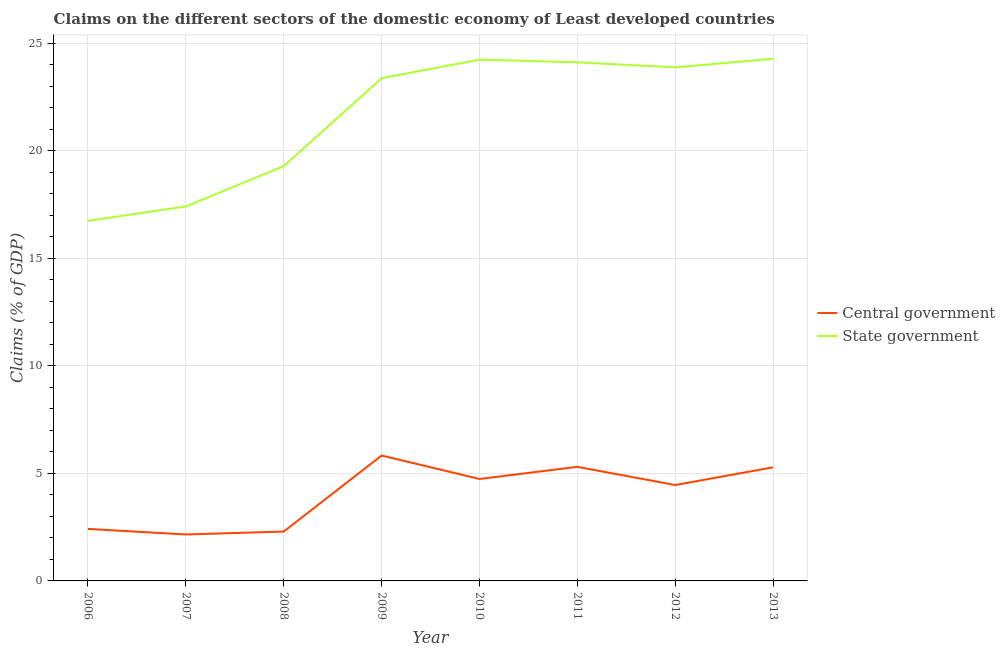Does the line corresponding to claims on central government intersect with the line corresponding to claims on state government?
Ensure brevity in your answer.  No. Is the number of lines equal to the number of legend labels?
Provide a succinct answer. Yes. What is the claims on central government in 2008?
Make the answer very short. 2.3. Across all years, what is the maximum claims on state government?
Make the answer very short. 24.27. Across all years, what is the minimum claims on central government?
Your answer should be very brief. 2.16. In which year was the claims on central government maximum?
Give a very brief answer. 2009. What is the total claims on central government in the graph?
Offer a terse response. 32.48. What is the difference between the claims on central government in 2007 and that in 2010?
Offer a terse response. -2.58. What is the difference between the claims on central government in 2011 and the claims on state government in 2009?
Your response must be concise. -18.06. What is the average claims on state government per year?
Ensure brevity in your answer.  21.66. In the year 2010, what is the difference between the claims on state government and claims on central government?
Your response must be concise. 19.49. What is the ratio of the claims on central government in 2008 to that in 2011?
Offer a very short reply. 0.43. Is the claims on central government in 2009 less than that in 2011?
Your response must be concise. No. What is the difference between the highest and the second highest claims on state government?
Keep it short and to the point. 0.05. What is the difference between the highest and the lowest claims on state government?
Provide a short and direct response. 7.54. In how many years, is the claims on state government greater than the average claims on state government taken over all years?
Provide a short and direct response. 5. Is the claims on state government strictly less than the claims on central government over the years?
Offer a very short reply. No. How many lines are there?
Provide a succinct answer. 2. Are the values on the major ticks of Y-axis written in scientific E-notation?
Ensure brevity in your answer.  No. Does the graph contain any zero values?
Ensure brevity in your answer.  No. How many legend labels are there?
Provide a short and direct response. 2. What is the title of the graph?
Keep it short and to the point. Claims on the different sectors of the domestic economy of Least developed countries. Does "Male labourers" appear as one of the legend labels in the graph?
Offer a terse response. No. What is the label or title of the Y-axis?
Your response must be concise. Claims (% of GDP). What is the Claims (% of GDP) of Central government in 2006?
Your answer should be compact. 2.42. What is the Claims (% of GDP) in State government in 2006?
Offer a terse response. 16.74. What is the Claims (% of GDP) in Central government in 2007?
Your response must be concise. 2.16. What is the Claims (% of GDP) in State government in 2007?
Your response must be concise. 17.41. What is the Claims (% of GDP) in Central government in 2008?
Make the answer very short. 2.3. What is the Claims (% of GDP) in State government in 2008?
Provide a succinct answer. 19.28. What is the Claims (% of GDP) of Central government in 2009?
Your response must be concise. 5.83. What is the Claims (% of GDP) of State government in 2009?
Ensure brevity in your answer.  23.37. What is the Claims (% of GDP) of Central government in 2010?
Keep it short and to the point. 4.74. What is the Claims (% of GDP) in State government in 2010?
Offer a terse response. 24.23. What is the Claims (% of GDP) of Central government in 2011?
Give a very brief answer. 5.3. What is the Claims (% of GDP) in State government in 2011?
Make the answer very short. 24.11. What is the Claims (% of GDP) of Central government in 2012?
Give a very brief answer. 4.46. What is the Claims (% of GDP) of State government in 2012?
Your answer should be very brief. 23.87. What is the Claims (% of GDP) in Central government in 2013?
Make the answer very short. 5.28. What is the Claims (% of GDP) in State government in 2013?
Provide a succinct answer. 24.27. Across all years, what is the maximum Claims (% of GDP) in Central government?
Provide a short and direct response. 5.83. Across all years, what is the maximum Claims (% of GDP) in State government?
Offer a very short reply. 24.27. Across all years, what is the minimum Claims (% of GDP) of Central government?
Provide a short and direct response. 2.16. Across all years, what is the minimum Claims (% of GDP) of State government?
Provide a short and direct response. 16.74. What is the total Claims (% of GDP) in Central government in the graph?
Keep it short and to the point. 32.48. What is the total Claims (% of GDP) in State government in the graph?
Provide a short and direct response. 173.27. What is the difference between the Claims (% of GDP) of Central government in 2006 and that in 2007?
Give a very brief answer. 0.26. What is the difference between the Claims (% of GDP) of State government in 2006 and that in 2007?
Offer a terse response. -0.67. What is the difference between the Claims (% of GDP) of Central government in 2006 and that in 2008?
Keep it short and to the point. 0.12. What is the difference between the Claims (% of GDP) in State government in 2006 and that in 2008?
Keep it short and to the point. -2.55. What is the difference between the Claims (% of GDP) in Central government in 2006 and that in 2009?
Offer a very short reply. -3.41. What is the difference between the Claims (% of GDP) of State government in 2006 and that in 2009?
Ensure brevity in your answer.  -6.63. What is the difference between the Claims (% of GDP) in Central government in 2006 and that in 2010?
Offer a very short reply. -2.32. What is the difference between the Claims (% of GDP) of State government in 2006 and that in 2010?
Your response must be concise. -7.49. What is the difference between the Claims (% of GDP) in Central government in 2006 and that in 2011?
Give a very brief answer. -2.89. What is the difference between the Claims (% of GDP) of State government in 2006 and that in 2011?
Provide a succinct answer. -7.37. What is the difference between the Claims (% of GDP) in Central government in 2006 and that in 2012?
Keep it short and to the point. -2.04. What is the difference between the Claims (% of GDP) of State government in 2006 and that in 2012?
Your response must be concise. -7.13. What is the difference between the Claims (% of GDP) in Central government in 2006 and that in 2013?
Provide a short and direct response. -2.86. What is the difference between the Claims (% of GDP) in State government in 2006 and that in 2013?
Offer a terse response. -7.54. What is the difference between the Claims (% of GDP) in Central government in 2007 and that in 2008?
Offer a very short reply. -0.14. What is the difference between the Claims (% of GDP) of State government in 2007 and that in 2008?
Offer a terse response. -1.88. What is the difference between the Claims (% of GDP) of Central government in 2007 and that in 2009?
Provide a short and direct response. -3.67. What is the difference between the Claims (% of GDP) of State government in 2007 and that in 2009?
Ensure brevity in your answer.  -5.96. What is the difference between the Claims (% of GDP) of Central government in 2007 and that in 2010?
Provide a short and direct response. -2.58. What is the difference between the Claims (% of GDP) in State government in 2007 and that in 2010?
Offer a very short reply. -6.82. What is the difference between the Claims (% of GDP) in Central government in 2007 and that in 2011?
Make the answer very short. -3.14. What is the difference between the Claims (% of GDP) of State government in 2007 and that in 2011?
Keep it short and to the point. -6.7. What is the difference between the Claims (% of GDP) in Central government in 2007 and that in 2012?
Your answer should be very brief. -2.3. What is the difference between the Claims (% of GDP) of State government in 2007 and that in 2012?
Give a very brief answer. -6.46. What is the difference between the Claims (% of GDP) of Central government in 2007 and that in 2013?
Keep it short and to the point. -3.12. What is the difference between the Claims (% of GDP) of State government in 2007 and that in 2013?
Offer a terse response. -6.87. What is the difference between the Claims (% of GDP) in Central government in 2008 and that in 2009?
Give a very brief answer. -3.53. What is the difference between the Claims (% of GDP) of State government in 2008 and that in 2009?
Provide a short and direct response. -4.08. What is the difference between the Claims (% of GDP) of Central government in 2008 and that in 2010?
Your answer should be compact. -2.44. What is the difference between the Claims (% of GDP) in State government in 2008 and that in 2010?
Offer a very short reply. -4.95. What is the difference between the Claims (% of GDP) of Central government in 2008 and that in 2011?
Offer a very short reply. -3.01. What is the difference between the Claims (% of GDP) of State government in 2008 and that in 2011?
Offer a very short reply. -4.82. What is the difference between the Claims (% of GDP) of Central government in 2008 and that in 2012?
Offer a terse response. -2.16. What is the difference between the Claims (% of GDP) in State government in 2008 and that in 2012?
Your response must be concise. -4.59. What is the difference between the Claims (% of GDP) of Central government in 2008 and that in 2013?
Your response must be concise. -2.99. What is the difference between the Claims (% of GDP) in State government in 2008 and that in 2013?
Offer a very short reply. -4.99. What is the difference between the Claims (% of GDP) in Central government in 2009 and that in 2010?
Your answer should be very brief. 1.09. What is the difference between the Claims (% of GDP) in State government in 2009 and that in 2010?
Your answer should be very brief. -0.86. What is the difference between the Claims (% of GDP) in Central government in 2009 and that in 2011?
Provide a succinct answer. 0.53. What is the difference between the Claims (% of GDP) of State government in 2009 and that in 2011?
Provide a succinct answer. -0.74. What is the difference between the Claims (% of GDP) of Central government in 2009 and that in 2012?
Make the answer very short. 1.37. What is the difference between the Claims (% of GDP) of State government in 2009 and that in 2012?
Ensure brevity in your answer.  -0.5. What is the difference between the Claims (% of GDP) of Central government in 2009 and that in 2013?
Offer a terse response. 0.55. What is the difference between the Claims (% of GDP) in State government in 2009 and that in 2013?
Your response must be concise. -0.91. What is the difference between the Claims (% of GDP) in Central government in 2010 and that in 2011?
Provide a succinct answer. -0.56. What is the difference between the Claims (% of GDP) in State government in 2010 and that in 2011?
Ensure brevity in your answer.  0.12. What is the difference between the Claims (% of GDP) of Central government in 2010 and that in 2012?
Provide a succinct answer. 0.28. What is the difference between the Claims (% of GDP) in State government in 2010 and that in 2012?
Your answer should be very brief. 0.36. What is the difference between the Claims (% of GDP) in Central government in 2010 and that in 2013?
Offer a very short reply. -0.54. What is the difference between the Claims (% of GDP) of State government in 2010 and that in 2013?
Your response must be concise. -0.05. What is the difference between the Claims (% of GDP) in Central government in 2011 and that in 2012?
Your answer should be compact. 0.85. What is the difference between the Claims (% of GDP) in State government in 2011 and that in 2012?
Offer a terse response. 0.24. What is the difference between the Claims (% of GDP) in Central government in 2011 and that in 2013?
Give a very brief answer. 0.02. What is the difference between the Claims (% of GDP) in State government in 2011 and that in 2013?
Keep it short and to the point. -0.17. What is the difference between the Claims (% of GDP) in Central government in 2012 and that in 2013?
Provide a short and direct response. -0.82. What is the difference between the Claims (% of GDP) in State government in 2012 and that in 2013?
Offer a terse response. -0.41. What is the difference between the Claims (% of GDP) in Central government in 2006 and the Claims (% of GDP) in State government in 2007?
Provide a short and direct response. -14.99. What is the difference between the Claims (% of GDP) of Central government in 2006 and the Claims (% of GDP) of State government in 2008?
Your answer should be compact. -16.86. What is the difference between the Claims (% of GDP) in Central government in 2006 and the Claims (% of GDP) in State government in 2009?
Offer a very short reply. -20.95. What is the difference between the Claims (% of GDP) in Central government in 2006 and the Claims (% of GDP) in State government in 2010?
Offer a terse response. -21.81. What is the difference between the Claims (% of GDP) in Central government in 2006 and the Claims (% of GDP) in State government in 2011?
Your answer should be compact. -21.69. What is the difference between the Claims (% of GDP) in Central government in 2006 and the Claims (% of GDP) in State government in 2012?
Your answer should be very brief. -21.45. What is the difference between the Claims (% of GDP) of Central government in 2006 and the Claims (% of GDP) of State government in 2013?
Give a very brief answer. -21.86. What is the difference between the Claims (% of GDP) in Central government in 2007 and the Claims (% of GDP) in State government in 2008?
Provide a short and direct response. -17.12. What is the difference between the Claims (% of GDP) of Central government in 2007 and the Claims (% of GDP) of State government in 2009?
Provide a short and direct response. -21.21. What is the difference between the Claims (% of GDP) in Central government in 2007 and the Claims (% of GDP) in State government in 2010?
Ensure brevity in your answer.  -22.07. What is the difference between the Claims (% of GDP) of Central government in 2007 and the Claims (% of GDP) of State government in 2011?
Give a very brief answer. -21.95. What is the difference between the Claims (% of GDP) of Central government in 2007 and the Claims (% of GDP) of State government in 2012?
Your response must be concise. -21.71. What is the difference between the Claims (% of GDP) of Central government in 2007 and the Claims (% of GDP) of State government in 2013?
Your answer should be compact. -22.12. What is the difference between the Claims (% of GDP) of Central government in 2008 and the Claims (% of GDP) of State government in 2009?
Keep it short and to the point. -21.07. What is the difference between the Claims (% of GDP) in Central government in 2008 and the Claims (% of GDP) in State government in 2010?
Your answer should be compact. -21.93. What is the difference between the Claims (% of GDP) of Central government in 2008 and the Claims (% of GDP) of State government in 2011?
Your answer should be very brief. -21.81. What is the difference between the Claims (% of GDP) in Central government in 2008 and the Claims (% of GDP) in State government in 2012?
Your response must be concise. -21.57. What is the difference between the Claims (% of GDP) of Central government in 2008 and the Claims (% of GDP) of State government in 2013?
Provide a succinct answer. -21.98. What is the difference between the Claims (% of GDP) in Central government in 2009 and the Claims (% of GDP) in State government in 2010?
Offer a terse response. -18.4. What is the difference between the Claims (% of GDP) of Central government in 2009 and the Claims (% of GDP) of State government in 2011?
Your answer should be compact. -18.28. What is the difference between the Claims (% of GDP) of Central government in 2009 and the Claims (% of GDP) of State government in 2012?
Offer a terse response. -18.04. What is the difference between the Claims (% of GDP) of Central government in 2009 and the Claims (% of GDP) of State government in 2013?
Your response must be concise. -18.45. What is the difference between the Claims (% of GDP) of Central government in 2010 and the Claims (% of GDP) of State government in 2011?
Your response must be concise. -19.37. What is the difference between the Claims (% of GDP) in Central government in 2010 and the Claims (% of GDP) in State government in 2012?
Ensure brevity in your answer.  -19.13. What is the difference between the Claims (% of GDP) of Central government in 2010 and the Claims (% of GDP) of State government in 2013?
Keep it short and to the point. -19.54. What is the difference between the Claims (% of GDP) in Central government in 2011 and the Claims (% of GDP) in State government in 2012?
Ensure brevity in your answer.  -18.57. What is the difference between the Claims (% of GDP) of Central government in 2011 and the Claims (% of GDP) of State government in 2013?
Your answer should be compact. -18.97. What is the difference between the Claims (% of GDP) of Central government in 2012 and the Claims (% of GDP) of State government in 2013?
Keep it short and to the point. -19.82. What is the average Claims (% of GDP) in Central government per year?
Provide a succinct answer. 4.06. What is the average Claims (% of GDP) in State government per year?
Your answer should be very brief. 21.66. In the year 2006, what is the difference between the Claims (% of GDP) in Central government and Claims (% of GDP) in State government?
Your answer should be very brief. -14.32. In the year 2007, what is the difference between the Claims (% of GDP) in Central government and Claims (% of GDP) in State government?
Provide a short and direct response. -15.25. In the year 2008, what is the difference between the Claims (% of GDP) in Central government and Claims (% of GDP) in State government?
Give a very brief answer. -16.99. In the year 2009, what is the difference between the Claims (% of GDP) of Central government and Claims (% of GDP) of State government?
Give a very brief answer. -17.54. In the year 2010, what is the difference between the Claims (% of GDP) of Central government and Claims (% of GDP) of State government?
Keep it short and to the point. -19.49. In the year 2011, what is the difference between the Claims (% of GDP) in Central government and Claims (% of GDP) in State government?
Provide a short and direct response. -18.8. In the year 2012, what is the difference between the Claims (% of GDP) of Central government and Claims (% of GDP) of State government?
Your response must be concise. -19.41. In the year 2013, what is the difference between the Claims (% of GDP) of Central government and Claims (% of GDP) of State government?
Provide a succinct answer. -18.99. What is the ratio of the Claims (% of GDP) of Central government in 2006 to that in 2007?
Your answer should be very brief. 1.12. What is the ratio of the Claims (% of GDP) of State government in 2006 to that in 2007?
Offer a very short reply. 0.96. What is the ratio of the Claims (% of GDP) in Central government in 2006 to that in 2008?
Your response must be concise. 1.05. What is the ratio of the Claims (% of GDP) in State government in 2006 to that in 2008?
Your answer should be very brief. 0.87. What is the ratio of the Claims (% of GDP) in Central government in 2006 to that in 2009?
Offer a terse response. 0.41. What is the ratio of the Claims (% of GDP) of State government in 2006 to that in 2009?
Your response must be concise. 0.72. What is the ratio of the Claims (% of GDP) in Central government in 2006 to that in 2010?
Give a very brief answer. 0.51. What is the ratio of the Claims (% of GDP) of State government in 2006 to that in 2010?
Give a very brief answer. 0.69. What is the ratio of the Claims (% of GDP) of Central government in 2006 to that in 2011?
Provide a short and direct response. 0.46. What is the ratio of the Claims (% of GDP) in State government in 2006 to that in 2011?
Keep it short and to the point. 0.69. What is the ratio of the Claims (% of GDP) of Central government in 2006 to that in 2012?
Provide a succinct answer. 0.54. What is the ratio of the Claims (% of GDP) in State government in 2006 to that in 2012?
Keep it short and to the point. 0.7. What is the ratio of the Claims (% of GDP) of Central government in 2006 to that in 2013?
Offer a very short reply. 0.46. What is the ratio of the Claims (% of GDP) in State government in 2006 to that in 2013?
Your answer should be compact. 0.69. What is the ratio of the Claims (% of GDP) in Central government in 2007 to that in 2008?
Your response must be concise. 0.94. What is the ratio of the Claims (% of GDP) of State government in 2007 to that in 2008?
Offer a terse response. 0.9. What is the ratio of the Claims (% of GDP) in Central government in 2007 to that in 2009?
Provide a short and direct response. 0.37. What is the ratio of the Claims (% of GDP) of State government in 2007 to that in 2009?
Your answer should be very brief. 0.74. What is the ratio of the Claims (% of GDP) in Central government in 2007 to that in 2010?
Keep it short and to the point. 0.46. What is the ratio of the Claims (% of GDP) of State government in 2007 to that in 2010?
Provide a succinct answer. 0.72. What is the ratio of the Claims (% of GDP) in Central government in 2007 to that in 2011?
Make the answer very short. 0.41. What is the ratio of the Claims (% of GDP) in State government in 2007 to that in 2011?
Offer a terse response. 0.72. What is the ratio of the Claims (% of GDP) of Central government in 2007 to that in 2012?
Ensure brevity in your answer.  0.48. What is the ratio of the Claims (% of GDP) in State government in 2007 to that in 2012?
Offer a very short reply. 0.73. What is the ratio of the Claims (% of GDP) of Central government in 2007 to that in 2013?
Your answer should be very brief. 0.41. What is the ratio of the Claims (% of GDP) in State government in 2007 to that in 2013?
Offer a terse response. 0.72. What is the ratio of the Claims (% of GDP) in Central government in 2008 to that in 2009?
Your answer should be very brief. 0.39. What is the ratio of the Claims (% of GDP) in State government in 2008 to that in 2009?
Offer a very short reply. 0.83. What is the ratio of the Claims (% of GDP) in Central government in 2008 to that in 2010?
Your response must be concise. 0.48. What is the ratio of the Claims (% of GDP) of State government in 2008 to that in 2010?
Offer a terse response. 0.8. What is the ratio of the Claims (% of GDP) of Central government in 2008 to that in 2011?
Offer a very short reply. 0.43. What is the ratio of the Claims (% of GDP) in State government in 2008 to that in 2011?
Your answer should be compact. 0.8. What is the ratio of the Claims (% of GDP) of Central government in 2008 to that in 2012?
Give a very brief answer. 0.51. What is the ratio of the Claims (% of GDP) in State government in 2008 to that in 2012?
Provide a short and direct response. 0.81. What is the ratio of the Claims (% of GDP) of Central government in 2008 to that in 2013?
Give a very brief answer. 0.43. What is the ratio of the Claims (% of GDP) in State government in 2008 to that in 2013?
Your answer should be very brief. 0.79. What is the ratio of the Claims (% of GDP) in Central government in 2009 to that in 2010?
Offer a very short reply. 1.23. What is the ratio of the Claims (% of GDP) in State government in 2009 to that in 2010?
Your answer should be compact. 0.96. What is the ratio of the Claims (% of GDP) in Central government in 2009 to that in 2011?
Your answer should be very brief. 1.1. What is the ratio of the Claims (% of GDP) of State government in 2009 to that in 2011?
Your answer should be very brief. 0.97. What is the ratio of the Claims (% of GDP) of Central government in 2009 to that in 2012?
Your answer should be very brief. 1.31. What is the ratio of the Claims (% of GDP) in State government in 2009 to that in 2012?
Provide a succinct answer. 0.98. What is the ratio of the Claims (% of GDP) of Central government in 2009 to that in 2013?
Offer a terse response. 1.1. What is the ratio of the Claims (% of GDP) of State government in 2009 to that in 2013?
Provide a succinct answer. 0.96. What is the ratio of the Claims (% of GDP) in Central government in 2010 to that in 2011?
Your answer should be very brief. 0.89. What is the ratio of the Claims (% of GDP) in State government in 2010 to that in 2011?
Provide a succinct answer. 1.01. What is the ratio of the Claims (% of GDP) of Central government in 2010 to that in 2012?
Provide a succinct answer. 1.06. What is the ratio of the Claims (% of GDP) of State government in 2010 to that in 2012?
Ensure brevity in your answer.  1.02. What is the ratio of the Claims (% of GDP) of Central government in 2010 to that in 2013?
Make the answer very short. 0.9. What is the ratio of the Claims (% of GDP) in Central government in 2011 to that in 2012?
Make the answer very short. 1.19. What is the ratio of the Claims (% of GDP) of State government in 2011 to that in 2012?
Offer a very short reply. 1.01. What is the ratio of the Claims (% of GDP) in Central government in 2012 to that in 2013?
Make the answer very short. 0.84. What is the ratio of the Claims (% of GDP) of State government in 2012 to that in 2013?
Your answer should be compact. 0.98. What is the difference between the highest and the second highest Claims (% of GDP) in Central government?
Ensure brevity in your answer.  0.53. What is the difference between the highest and the second highest Claims (% of GDP) in State government?
Offer a very short reply. 0.05. What is the difference between the highest and the lowest Claims (% of GDP) in Central government?
Offer a very short reply. 3.67. What is the difference between the highest and the lowest Claims (% of GDP) in State government?
Your response must be concise. 7.54. 